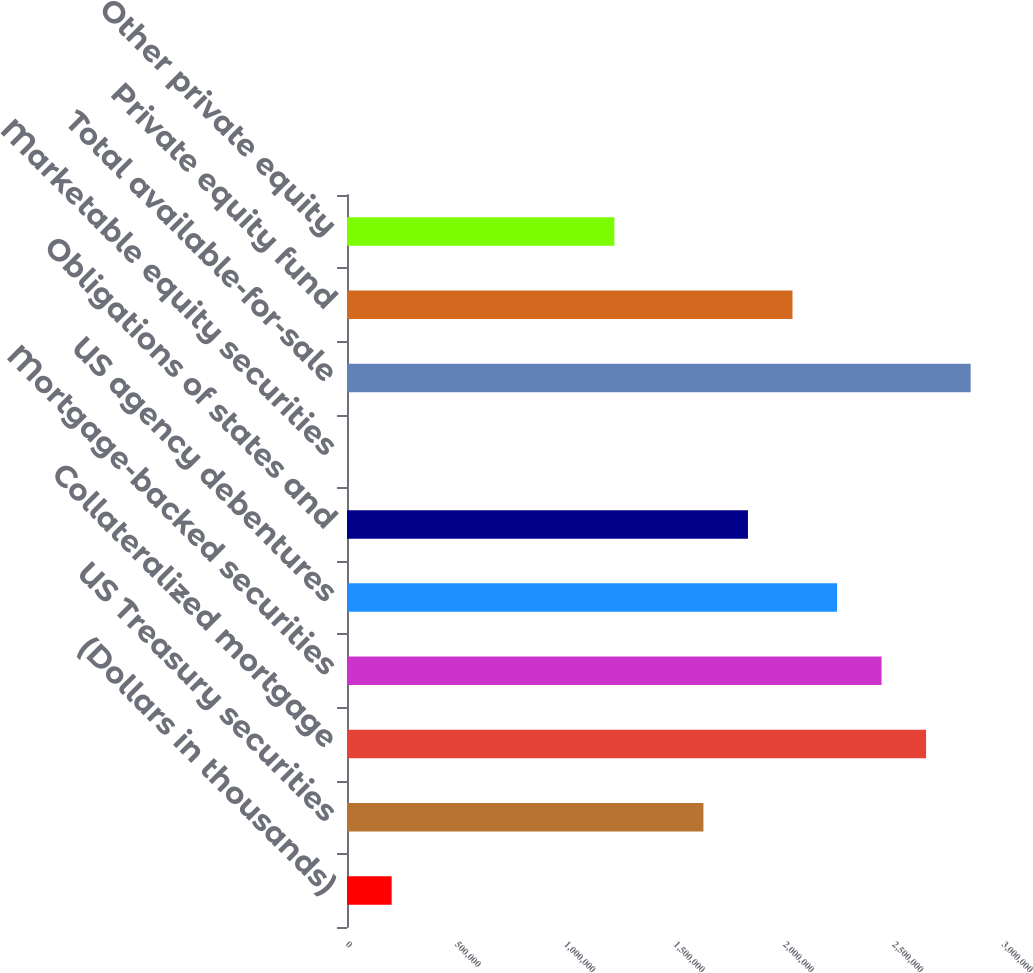Convert chart to OTSL. <chart><loc_0><loc_0><loc_500><loc_500><bar_chart><fcel>(Dollars in thousands)<fcel>US Treasury securities<fcel>Collateralized mortgage<fcel>Mortgage-backed securities<fcel>US agency debentures<fcel>Obligations of states and<fcel>Marketable equity securities<fcel>Total available-for-sale<fcel>Private equity fund<fcel>Other private equity<nl><fcel>204297<fcel>1.62994e+06<fcel>2.64826e+06<fcel>2.4446e+06<fcel>2.24093e+06<fcel>1.83361e+06<fcel>633<fcel>2.85192e+06<fcel>2.03727e+06<fcel>1.22262e+06<nl></chart> 